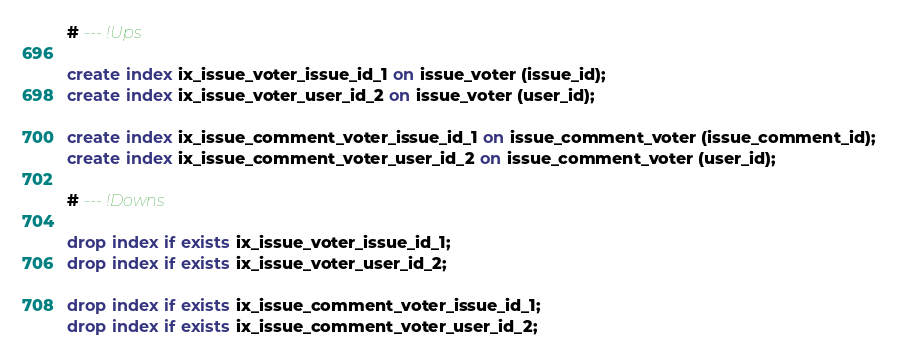<code> <loc_0><loc_0><loc_500><loc_500><_SQL_># --- !Ups

create index ix_issue_voter_issue_id_1 on issue_voter (issue_id);
create index ix_issue_voter_user_id_2 on issue_voter (user_id);

create index ix_issue_comment_voter_issue_id_1 on issue_comment_voter (issue_comment_id);
create index ix_issue_comment_voter_user_id_2 on issue_comment_voter (user_id);

# --- !Downs

drop index if exists ix_issue_voter_issue_id_1;
drop index if exists ix_issue_voter_user_id_2;

drop index if exists ix_issue_comment_voter_issue_id_1;
drop index if exists ix_issue_comment_voter_user_id_2;
</code> 